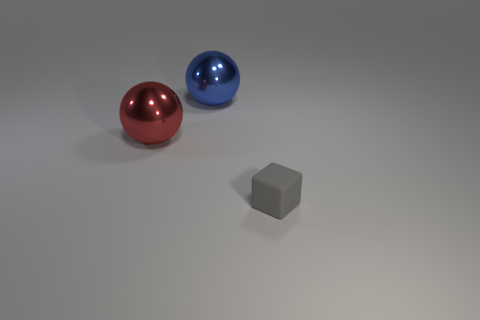There is a big red sphere; how many blue metal balls are in front of it? In the image, you can see a big red sphere placed to the left and a smaller, blue sphere to the right. Directly in front of the big red sphere, there are no objects; however, the blue sphere is in front when looking from the red sphere's perspective. 